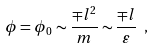<formula> <loc_0><loc_0><loc_500><loc_500>\phi = \phi _ { 0 } \sim \frac { \mp l ^ { 2 } } { m } \sim \frac { \mp l } { \varepsilon } \ ,</formula> 